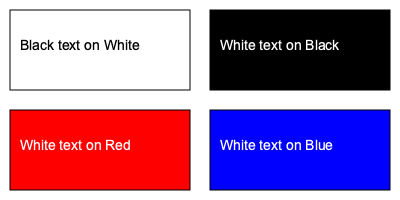Which of the color combinations shown in the image has the highest contrast ratio, making it the most accessible for web users? To determine the color combination with the highest contrast ratio, we need to understand how contrast ratios are calculated and compare them for each combination:

1. Contrast ratio formula: $$(L1 + 0.05) / (L2 + 0.05)$$, where L1 is the lighter color's relative luminance and L2 is the darker color's relative luminance.

2. Relative luminance for sRGB colors: $$L = 0.2126 * R + 0.7152 * G + 0.0722 * B$$, where R, G, and B are the color values divided by 255.

3. Calculating luminance for each color:
   - White (#FFFFFF): $L_{white} = 0.2126 * 1 + 0.7152 * 1 + 0.0722 * 1 = 1$
   - Black (#000000): $L_{black} = 0.2126 * 0 + 0.7152 * 0 + 0.0722 * 0 = 0$
   - Red (#FF0000): $L_{red} = 0.2126 * 1 + 0.7152 * 0 + 0.0722 * 0 = 0.2126$
   - Blue (#0000FF): $L_{blue} = 0.2126 * 0 + 0.7152 * 0 + 0.0722 * 1 = 0.0722$

4. Calculating contrast ratios:
   - Black on White: $$(1 + 0.05) / (0 + 0.05) = 21$$
   - White on Black: $$(1 + 0.05) / (0 + 0.05) = 21$$
   - White on Red: $$(1 + 0.05) / (0.2126 + 0.05) = 4.0$$
   - White on Blue: $$(1 + 0.05) / (0.0722 + 0.05) = 8.6$$

5. Comparing the ratios, we can see that Black on White and White on Black have the highest contrast ratio of 21:1.
Answer: Black on White or White on Black (21:1 contrast ratio) 